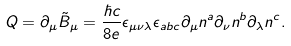<formula> <loc_0><loc_0><loc_500><loc_500>Q = \partial _ { \mu } \tilde { B } _ { \mu } = \frac { \hbar { c } } { 8 e } \epsilon _ { \mu \nu \lambda } \epsilon _ { a b c } \partial _ { \mu } n ^ { a } \partial _ { \nu } n ^ { b } \partial _ { \lambda } n ^ { c } .</formula> 